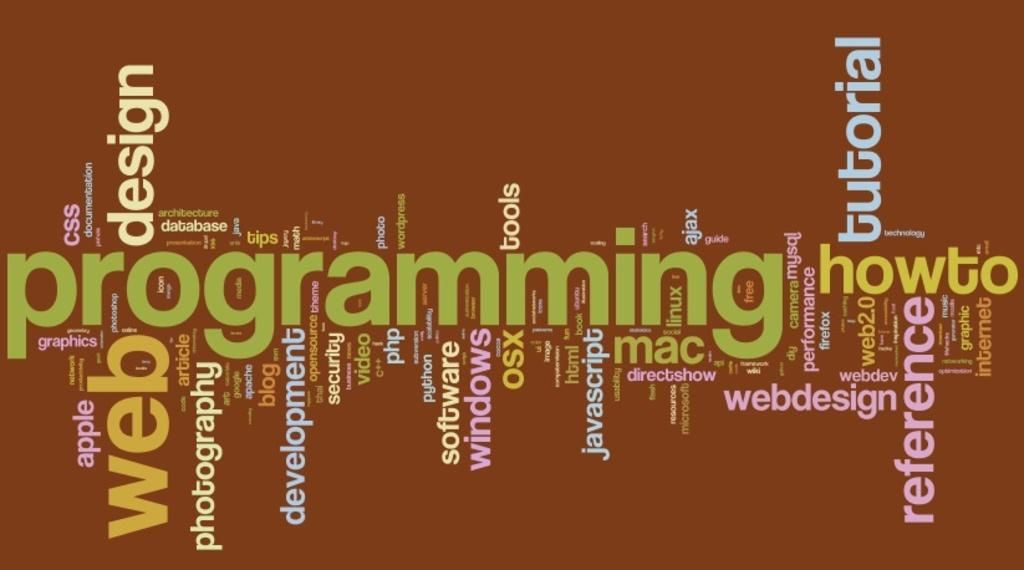<image>
Share a concise interpretation of the image provided. a poster in dark orange about programming and web design 